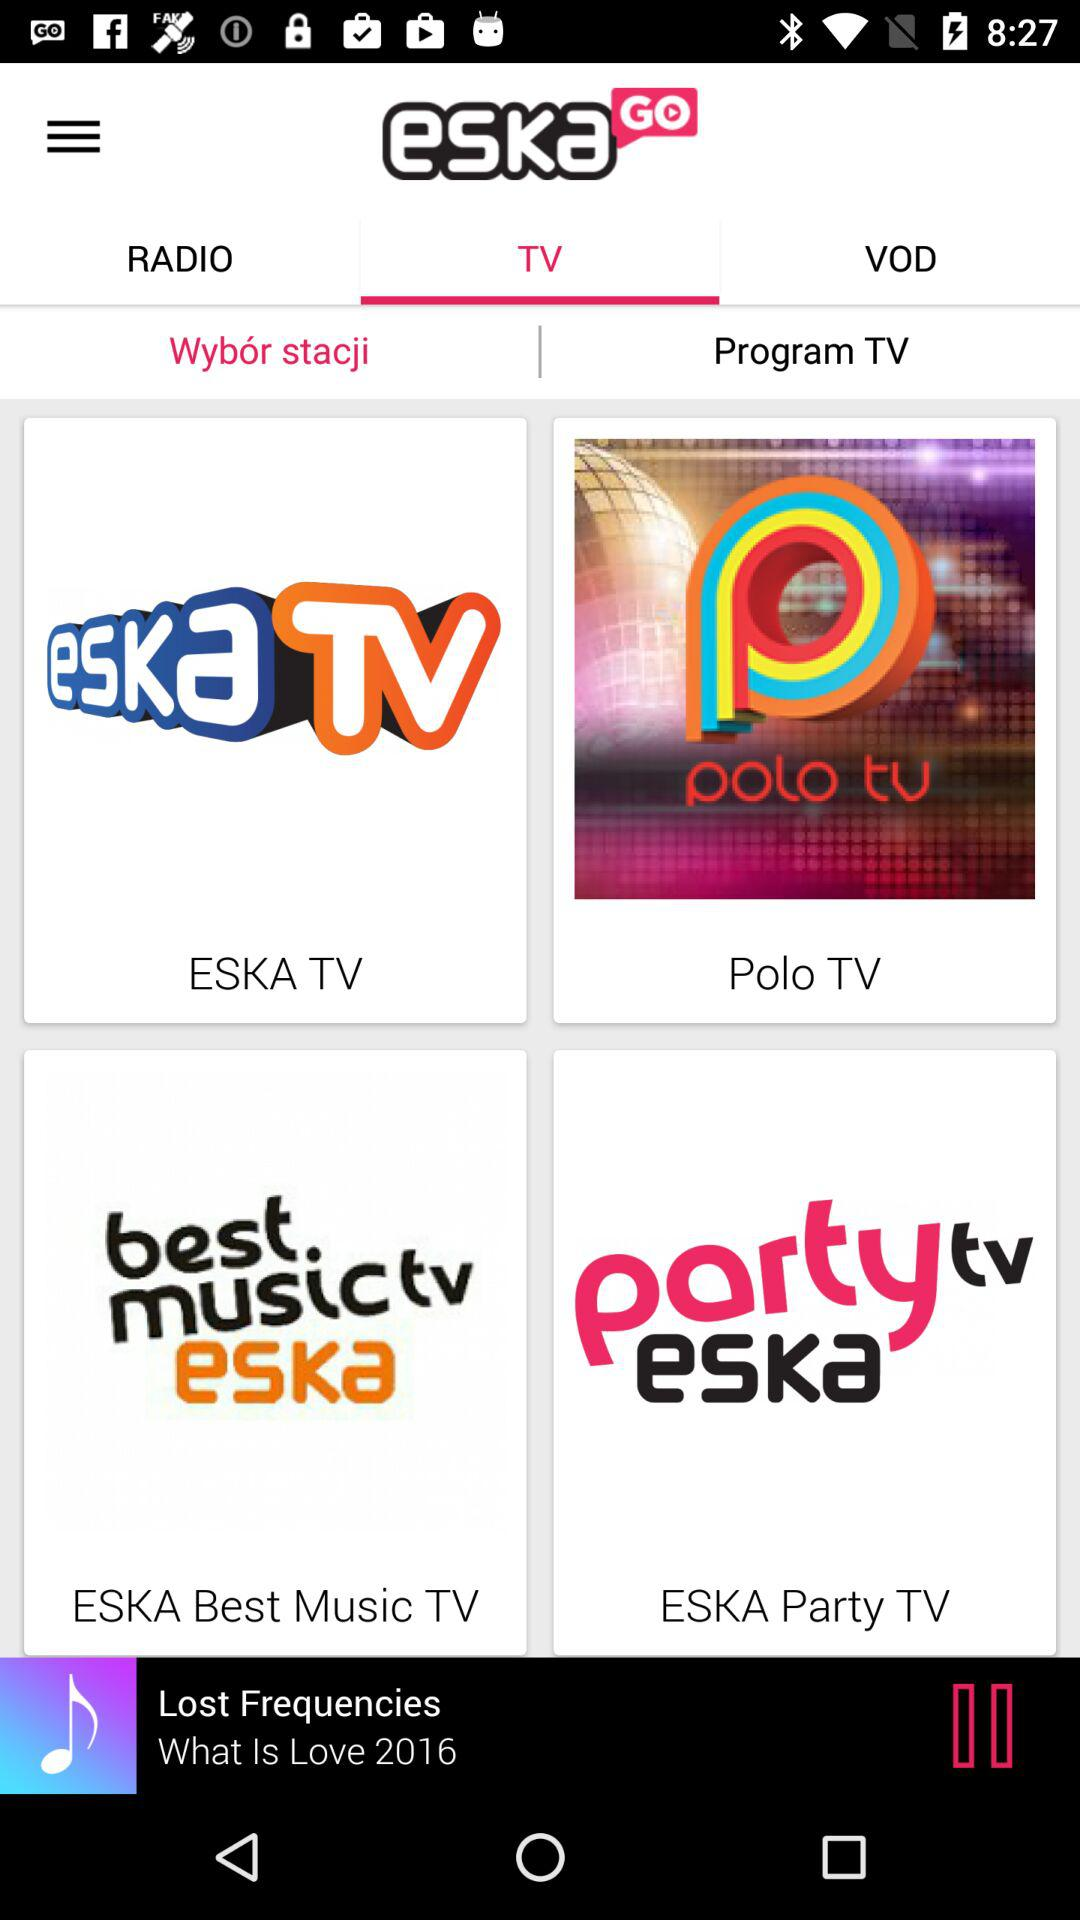What is the name of the application? The name of the application is "eskaGo". 